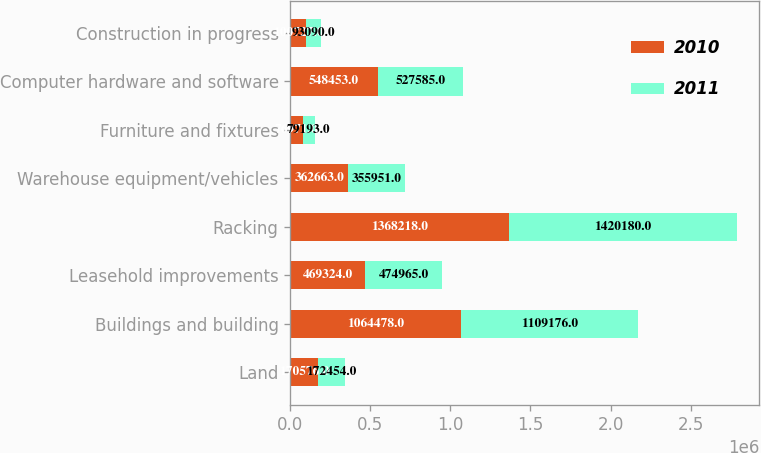Convert chart to OTSL. <chart><loc_0><loc_0><loc_500><loc_500><stacked_bar_chart><ecel><fcel>Land<fcel>Buildings and building<fcel>Leasehold improvements<fcel>Racking<fcel>Warehouse equipment/vehicles<fcel>Furniture and fixtures<fcel>Computer hardware and software<fcel>Construction in progress<nl><fcel>2010<fcel>170576<fcel>1.06448e+06<fcel>469324<fcel>1.36822e+06<fcel>362663<fcel>76971<fcel>548453<fcel>100727<nl><fcel>2011<fcel>172454<fcel>1.10918e+06<fcel>474965<fcel>1.42018e+06<fcel>355951<fcel>79193<fcel>527585<fcel>93090<nl></chart> 